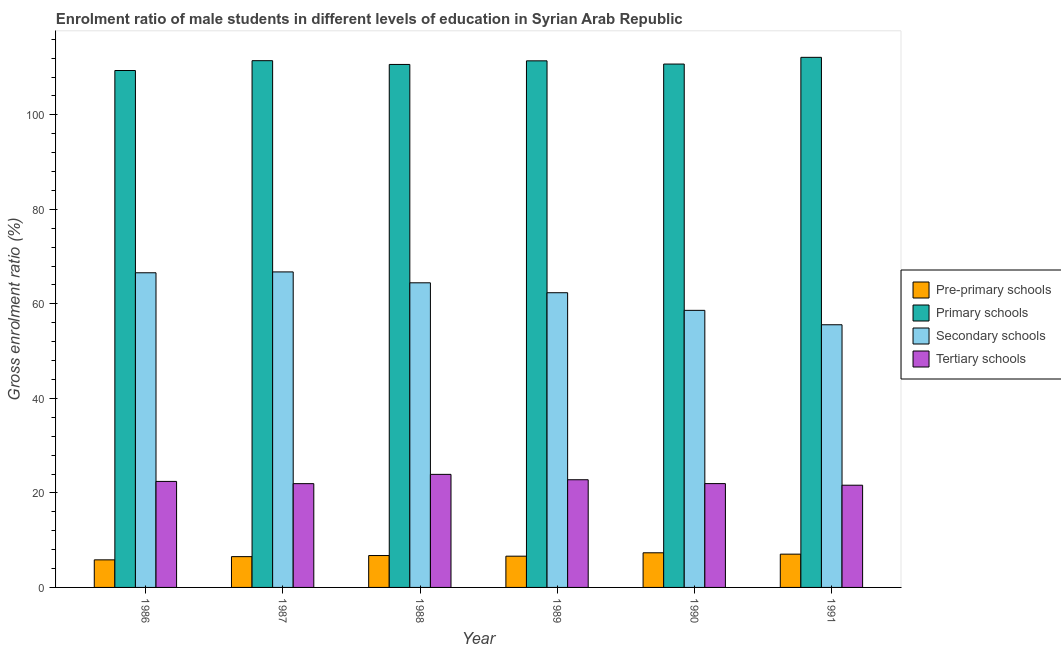How many groups of bars are there?
Keep it short and to the point. 6. How many bars are there on the 6th tick from the left?
Provide a succinct answer. 4. In how many cases, is the number of bars for a given year not equal to the number of legend labels?
Keep it short and to the point. 0. What is the gross enrolment ratio(female) in primary schools in 1990?
Ensure brevity in your answer.  110.74. Across all years, what is the maximum gross enrolment ratio(female) in pre-primary schools?
Your response must be concise. 7.33. Across all years, what is the minimum gross enrolment ratio(female) in secondary schools?
Offer a terse response. 55.58. In which year was the gross enrolment ratio(female) in pre-primary schools maximum?
Your response must be concise. 1990. What is the total gross enrolment ratio(female) in pre-primary schools in the graph?
Keep it short and to the point. 40.08. What is the difference between the gross enrolment ratio(female) in secondary schools in 1987 and that in 1988?
Provide a succinct answer. 2.3. What is the difference between the gross enrolment ratio(female) in pre-primary schools in 1989 and the gross enrolment ratio(female) in tertiary schools in 1990?
Provide a short and direct response. -0.72. What is the average gross enrolment ratio(female) in primary schools per year?
Provide a succinct answer. 110.97. What is the ratio of the gross enrolment ratio(female) in tertiary schools in 1990 to that in 1991?
Your response must be concise. 1.02. Is the gross enrolment ratio(female) in tertiary schools in 1987 less than that in 1990?
Offer a terse response. Yes. What is the difference between the highest and the second highest gross enrolment ratio(female) in pre-primary schools?
Provide a short and direct response. 0.29. What is the difference between the highest and the lowest gross enrolment ratio(female) in pre-primary schools?
Your answer should be very brief. 1.49. Is the sum of the gross enrolment ratio(female) in tertiary schools in 1987 and 1991 greater than the maximum gross enrolment ratio(female) in primary schools across all years?
Provide a succinct answer. Yes. What does the 3rd bar from the left in 1987 represents?
Your answer should be compact. Secondary schools. What does the 1st bar from the right in 1990 represents?
Offer a very short reply. Tertiary schools. Is it the case that in every year, the sum of the gross enrolment ratio(female) in pre-primary schools and gross enrolment ratio(female) in primary schools is greater than the gross enrolment ratio(female) in secondary schools?
Make the answer very short. Yes. How many bars are there?
Your answer should be compact. 24. How many years are there in the graph?
Your answer should be very brief. 6. Does the graph contain any zero values?
Give a very brief answer. No. Where does the legend appear in the graph?
Offer a terse response. Center right. How many legend labels are there?
Keep it short and to the point. 4. How are the legend labels stacked?
Keep it short and to the point. Vertical. What is the title of the graph?
Offer a very short reply. Enrolment ratio of male students in different levels of education in Syrian Arab Republic. Does "Quality of logistic services" appear as one of the legend labels in the graph?
Your answer should be compact. No. What is the label or title of the X-axis?
Your answer should be compact. Year. What is the label or title of the Y-axis?
Keep it short and to the point. Gross enrolment ratio (%). What is the Gross enrolment ratio (%) in Pre-primary schools in 1986?
Your response must be concise. 5.84. What is the Gross enrolment ratio (%) of Primary schools in 1986?
Ensure brevity in your answer.  109.38. What is the Gross enrolment ratio (%) of Secondary schools in 1986?
Offer a terse response. 66.58. What is the Gross enrolment ratio (%) of Tertiary schools in 1986?
Your answer should be very brief. 22.43. What is the Gross enrolment ratio (%) in Pre-primary schools in 1987?
Ensure brevity in your answer.  6.52. What is the Gross enrolment ratio (%) of Primary schools in 1987?
Offer a terse response. 111.46. What is the Gross enrolment ratio (%) of Secondary schools in 1987?
Make the answer very short. 66.76. What is the Gross enrolment ratio (%) of Tertiary schools in 1987?
Provide a succinct answer. 21.96. What is the Gross enrolment ratio (%) of Pre-primary schools in 1988?
Your answer should be compact. 6.75. What is the Gross enrolment ratio (%) in Primary schools in 1988?
Make the answer very short. 110.66. What is the Gross enrolment ratio (%) of Secondary schools in 1988?
Your response must be concise. 64.46. What is the Gross enrolment ratio (%) of Tertiary schools in 1988?
Provide a short and direct response. 23.92. What is the Gross enrolment ratio (%) of Pre-primary schools in 1989?
Keep it short and to the point. 6.61. What is the Gross enrolment ratio (%) of Primary schools in 1989?
Your response must be concise. 111.42. What is the Gross enrolment ratio (%) of Secondary schools in 1989?
Provide a short and direct response. 62.36. What is the Gross enrolment ratio (%) in Tertiary schools in 1989?
Your answer should be very brief. 22.78. What is the Gross enrolment ratio (%) of Pre-primary schools in 1990?
Provide a succinct answer. 7.33. What is the Gross enrolment ratio (%) in Primary schools in 1990?
Make the answer very short. 110.74. What is the Gross enrolment ratio (%) in Secondary schools in 1990?
Make the answer very short. 58.63. What is the Gross enrolment ratio (%) of Tertiary schools in 1990?
Provide a succinct answer. 21.97. What is the Gross enrolment ratio (%) of Pre-primary schools in 1991?
Provide a short and direct response. 7.04. What is the Gross enrolment ratio (%) in Primary schools in 1991?
Your answer should be compact. 112.17. What is the Gross enrolment ratio (%) in Secondary schools in 1991?
Provide a short and direct response. 55.58. What is the Gross enrolment ratio (%) of Tertiary schools in 1991?
Offer a very short reply. 21.63. Across all years, what is the maximum Gross enrolment ratio (%) of Pre-primary schools?
Your answer should be very brief. 7.33. Across all years, what is the maximum Gross enrolment ratio (%) in Primary schools?
Provide a succinct answer. 112.17. Across all years, what is the maximum Gross enrolment ratio (%) in Secondary schools?
Provide a short and direct response. 66.76. Across all years, what is the maximum Gross enrolment ratio (%) of Tertiary schools?
Keep it short and to the point. 23.92. Across all years, what is the minimum Gross enrolment ratio (%) in Pre-primary schools?
Ensure brevity in your answer.  5.84. Across all years, what is the minimum Gross enrolment ratio (%) in Primary schools?
Your answer should be compact. 109.38. Across all years, what is the minimum Gross enrolment ratio (%) of Secondary schools?
Provide a succinct answer. 55.58. Across all years, what is the minimum Gross enrolment ratio (%) in Tertiary schools?
Your answer should be compact. 21.63. What is the total Gross enrolment ratio (%) in Pre-primary schools in the graph?
Offer a very short reply. 40.08. What is the total Gross enrolment ratio (%) of Primary schools in the graph?
Offer a very short reply. 665.83. What is the total Gross enrolment ratio (%) of Secondary schools in the graph?
Ensure brevity in your answer.  374.36. What is the total Gross enrolment ratio (%) of Tertiary schools in the graph?
Provide a short and direct response. 134.69. What is the difference between the Gross enrolment ratio (%) in Pre-primary schools in 1986 and that in 1987?
Give a very brief answer. -0.68. What is the difference between the Gross enrolment ratio (%) of Primary schools in 1986 and that in 1987?
Keep it short and to the point. -2.08. What is the difference between the Gross enrolment ratio (%) in Secondary schools in 1986 and that in 1987?
Give a very brief answer. -0.18. What is the difference between the Gross enrolment ratio (%) of Tertiary schools in 1986 and that in 1987?
Offer a terse response. 0.47. What is the difference between the Gross enrolment ratio (%) of Pre-primary schools in 1986 and that in 1988?
Provide a short and direct response. -0.91. What is the difference between the Gross enrolment ratio (%) in Primary schools in 1986 and that in 1988?
Keep it short and to the point. -1.28. What is the difference between the Gross enrolment ratio (%) of Secondary schools in 1986 and that in 1988?
Provide a short and direct response. 2.12. What is the difference between the Gross enrolment ratio (%) in Tertiary schools in 1986 and that in 1988?
Offer a very short reply. -1.49. What is the difference between the Gross enrolment ratio (%) of Pre-primary schools in 1986 and that in 1989?
Provide a succinct answer. -0.78. What is the difference between the Gross enrolment ratio (%) in Primary schools in 1986 and that in 1989?
Offer a terse response. -2.05. What is the difference between the Gross enrolment ratio (%) of Secondary schools in 1986 and that in 1989?
Your response must be concise. 4.22. What is the difference between the Gross enrolment ratio (%) of Tertiary schools in 1986 and that in 1989?
Give a very brief answer. -0.35. What is the difference between the Gross enrolment ratio (%) of Pre-primary schools in 1986 and that in 1990?
Your answer should be very brief. -1.49. What is the difference between the Gross enrolment ratio (%) of Primary schools in 1986 and that in 1990?
Give a very brief answer. -1.37. What is the difference between the Gross enrolment ratio (%) in Secondary schools in 1986 and that in 1990?
Offer a terse response. 7.95. What is the difference between the Gross enrolment ratio (%) of Tertiary schools in 1986 and that in 1990?
Offer a very short reply. 0.47. What is the difference between the Gross enrolment ratio (%) in Pre-primary schools in 1986 and that in 1991?
Your answer should be compact. -1.21. What is the difference between the Gross enrolment ratio (%) of Primary schools in 1986 and that in 1991?
Provide a short and direct response. -2.79. What is the difference between the Gross enrolment ratio (%) of Secondary schools in 1986 and that in 1991?
Offer a very short reply. 11. What is the difference between the Gross enrolment ratio (%) in Tertiary schools in 1986 and that in 1991?
Make the answer very short. 0.8. What is the difference between the Gross enrolment ratio (%) in Pre-primary schools in 1987 and that in 1988?
Give a very brief answer. -0.23. What is the difference between the Gross enrolment ratio (%) of Primary schools in 1987 and that in 1988?
Your answer should be very brief. 0.8. What is the difference between the Gross enrolment ratio (%) of Secondary schools in 1987 and that in 1988?
Offer a very short reply. 2.3. What is the difference between the Gross enrolment ratio (%) of Tertiary schools in 1987 and that in 1988?
Keep it short and to the point. -1.96. What is the difference between the Gross enrolment ratio (%) in Pre-primary schools in 1987 and that in 1989?
Provide a short and direct response. -0.1. What is the difference between the Gross enrolment ratio (%) of Primary schools in 1987 and that in 1989?
Make the answer very short. 0.03. What is the difference between the Gross enrolment ratio (%) of Secondary schools in 1987 and that in 1989?
Ensure brevity in your answer.  4.4. What is the difference between the Gross enrolment ratio (%) of Tertiary schools in 1987 and that in 1989?
Give a very brief answer. -0.82. What is the difference between the Gross enrolment ratio (%) of Pre-primary schools in 1987 and that in 1990?
Your answer should be compact. -0.81. What is the difference between the Gross enrolment ratio (%) of Primary schools in 1987 and that in 1990?
Give a very brief answer. 0.71. What is the difference between the Gross enrolment ratio (%) in Secondary schools in 1987 and that in 1990?
Make the answer very short. 8.13. What is the difference between the Gross enrolment ratio (%) in Tertiary schools in 1987 and that in 1990?
Offer a terse response. -0.01. What is the difference between the Gross enrolment ratio (%) of Pre-primary schools in 1987 and that in 1991?
Offer a terse response. -0.53. What is the difference between the Gross enrolment ratio (%) in Primary schools in 1987 and that in 1991?
Make the answer very short. -0.71. What is the difference between the Gross enrolment ratio (%) in Secondary schools in 1987 and that in 1991?
Your answer should be very brief. 11.18. What is the difference between the Gross enrolment ratio (%) in Tertiary schools in 1987 and that in 1991?
Keep it short and to the point. 0.33. What is the difference between the Gross enrolment ratio (%) in Pre-primary schools in 1988 and that in 1989?
Give a very brief answer. 0.14. What is the difference between the Gross enrolment ratio (%) of Primary schools in 1988 and that in 1989?
Provide a short and direct response. -0.76. What is the difference between the Gross enrolment ratio (%) of Secondary schools in 1988 and that in 1989?
Your response must be concise. 2.1. What is the difference between the Gross enrolment ratio (%) of Tertiary schools in 1988 and that in 1989?
Offer a very short reply. 1.14. What is the difference between the Gross enrolment ratio (%) of Pre-primary schools in 1988 and that in 1990?
Provide a short and direct response. -0.58. What is the difference between the Gross enrolment ratio (%) in Primary schools in 1988 and that in 1990?
Your response must be concise. -0.08. What is the difference between the Gross enrolment ratio (%) of Secondary schools in 1988 and that in 1990?
Offer a terse response. 5.83. What is the difference between the Gross enrolment ratio (%) in Tertiary schools in 1988 and that in 1990?
Give a very brief answer. 1.95. What is the difference between the Gross enrolment ratio (%) in Pre-primary schools in 1988 and that in 1991?
Provide a succinct answer. -0.3. What is the difference between the Gross enrolment ratio (%) in Primary schools in 1988 and that in 1991?
Your response must be concise. -1.51. What is the difference between the Gross enrolment ratio (%) of Secondary schools in 1988 and that in 1991?
Provide a short and direct response. 8.88. What is the difference between the Gross enrolment ratio (%) of Tertiary schools in 1988 and that in 1991?
Give a very brief answer. 2.29. What is the difference between the Gross enrolment ratio (%) of Pre-primary schools in 1989 and that in 1990?
Ensure brevity in your answer.  -0.72. What is the difference between the Gross enrolment ratio (%) in Primary schools in 1989 and that in 1990?
Your answer should be very brief. 0.68. What is the difference between the Gross enrolment ratio (%) in Secondary schools in 1989 and that in 1990?
Make the answer very short. 3.73. What is the difference between the Gross enrolment ratio (%) of Tertiary schools in 1989 and that in 1990?
Make the answer very short. 0.82. What is the difference between the Gross enrolment ratio (%) in Pre-primary schools in 1989 and that in 1991?
Your answer should be compact. -0.43. What is the difference between the Gross enrolment ratio (%) of Primary schools in 1989 and that in 1991?
Provide a succinct answer. -0.74. What is the difference between the Gross enrolment ratio (%) in Secondary schools in 1989 and that in 1991?
Your answer should be compact. 6.78. What is the difference between the Gross enrolment ratio (%) of Tertiary schools in 1989 and that in 1991?
Keep it short and to the point. 1.15. What is the difference between the Gross enrolment ratio (%) in Pre-primary schools in 1990 and that in 1991?
Give a very brief answer. 0.29. What is the difference between the Gross enrolment ratio (%) in Primary schools in 1990 and that in 1991?
Ensure brevity in your answer.  -1.42. What is the difference between the Gross enrolment ratio (%) in Secondary schools in 1990 and that in 1991?
Give a very brief answer. 3.05. What is the difference between the Gross enrolment ratio (%) of Tertiary schools in 1990 and that in 1991?
Provide a short and direct response. 0.34. What is the difference between the Gross enrolment ratio (%) of Pre-primary schools in 1986 and the Gross enrolment ratio (%) of Primary schools in 1987?
Make the answer very short. -105.62. What is the difference between the Gross enrolment ratio (%) of Pre-primary schools in 1986 and the Gross enrolment ratio (%) of Secondary schools in 1987?
Offer a very short reply. -60.93. What is the difference between the Gross enrolment ratio (%) of Pre-primary schools in 1986 and the Gross enrolment ratio (%) of Tertiary schools in 1987?
Your answer should be very brief. -16.12. What is the difference between the Gross enrolment ratio (%) of Primary schools in 1986 and the Gross enrolment ratio (%) of Secondary schools in 1987?
Your answer should be compact. 42.62. What is the difference between the Gross enrolment ratio (%) in Primary schools in 1986 and the Gross enrolment ratio (%) in Tertiary schools in 1987?
Your answer should be compact. 87.42. What is the difference between the Gross enrolment ratio (%) of Secondary schools in 1986 and the Gross enrolment ratio (%) of Tertiary schools in 1987?
Keep it short and to the point. 44.62. What is the difference between the Gross enrolment ratio (%) in Pre-primary schools in 1986 and the Gross enrolment ratio (%) in Primary schools in 1988?
Offer a very short reply. -104.83. What is the difference between the Gross enrolment ratio (%) in Pre-primary schools in 1986 and the Gross enrolment ratio (%) in Secondary schools in 1988?
Keep it short and to the point. -58.62. What is the difference between the Gross enrolment ratio (%) in Pre-primary schools in 1986 and the Gross enrolment ratio (%) in Tertiary schools in 1988?
Ensure brevity in your answer.  -18.09. What is the difference between the Gross enrolment ratio (%) in Primary schools in 1986 and the Gross enrolment ratio (%) in Secondary schools in 1988?
Make the answer very short. 44.92. What is the difference between the Gross enrolment ratio (%) in Primary schools in 1986 and the Gross enrolment ratio (%) in Tertiary schools in 1988?
Your answer should be very brief. 85.46. What is the difference between the Gross enrolment ratio (%) of Secondary schools in 1986 and the Gross enrolment ratio (%) of Tertiary schools in 1988?
Provide a succinct answer. 42.66. What is the difference between the Gross enrolment ratio (%) in Pre-primary schools in 1986 and the Gross enrolment ratio (%) in Primary schools in 1989?
Ensure brevity in your answer.  -105.59. What is the difference between the Gross enrolment ratio (%) in Pre-primary schools in 1986 and the Gross enrolment ratio (%) in Secondary schools in 1989?
Offer a very short reply. -56.52. What is the difference between the Gross enrolment ratio (%) in Pre-primary schools in 1986 and the Gross enrolment ratio (%) in Tertiary schools in 1989?
Ensure brevity in your answer.  -16.95. What is the difference between the Gross enrolment ratio (%) of Primary schools in 1986 and the Gross enrolment ratio (%) of Secondary schools in 1989?
Make the answer very short. 47.02. What is the difference between the Gross enrolment ratio (%) of Primary schools in 1986 and the Gross enrolment ratio (%) of Tertiary schools in 1989?
Provide a short and direct response. 86.59. What is the difference between the Gross enrolment ratio (%) of Secondary schools in 1986 and the Gross enrolment ratio (%) of Tertiary schools in 1989?
Offer a terse response. 43.8. What is the difference between the Gross enrolment ratio (%) of Pre-primary schools in 1986 and the Gross enrolment ratio (%) of Primary schools in 1990?
Give a very brief answer. -104.91. What is the difference between the Gross enrolment ratio (%) of Pre-primary schools in 1986 and the Gross enrolment ratio (%) of Secondary schools in 1990?
Give a very brief answer. -52.79. What is the difference between the Gross enrolment ratio (%) of Pre-primary schools in 1986 and the Gross enrolment ratio (%) of Tertiary schools in 1990?
Provide a short and direct response. -16.13. What is the difference between the Gross enrolment ratio (%) of Primary schools in 1986 and the Gross enrolment ratio (%) of Secondary schools in 1990?
Offer a very short reply. 50.75. What is the difference between the Gross enrolment ratio (%) of Primary schools in 1986 and the Gross enrolment ratio (%) of Tertiary schools in 1990?
Your answer should be compact. 87.41. What is the difference between the Gross enrolment ratio (%) in Secondary schools in 1986 and the Gross enrolment ratio (%) in Tertiary schools in 1990?
Your answer should be very brief. 44.61. What is the difference between the Gross enrolment ratio (%) of Pre-primary schools in 1986 and the Gross enrolment ratio (%) of Primary schools in 1991?
Offer a terse response. -106.33. What is the difference between the Gross enrolment ratio (%) in Pre-primary schools in 1986 and the Gross enrolment ratio (%) in Secondary schools in 1991?
Ensure brevity in your answer.  -49.74. What is the difference between the Gross enrolment ratio (%) in Pre-primary schools in 1986 and the Gross enrolment ratio (%) in Tertiary schools in 1991?
Keep it short and to the point. -15.79. What is the difference between the Gross enrolment ratio (%) in Primary schools in 1986 and the Gross enrolment ratio (%) in Secondary schools in 1991?
Provide a short and direct response. 53.8. What is the difference between the Gross enrolment ratio (%) of Primary schools in 1986 and the Gross enrolment ratio (%) of Tertiary schools in 1991?
Keep it short and to the point. 87.75. What is the difference between the Gross enrolment ratio (%) of Secondary schools in 1986 and the Gross enrolment ratio (%) of Tertiary schools in 1991?
Give a very brief answer. 44.95. What is the difference between the Gross enrolment ratio (%) of Pre-primary schools in 1987 and the Gross enrolment ratio (%) of Primary schools in 1988?
Your answer should be compact. -104.15. What is the difference between the Gross enrolment ratio (%) of Pre-primary schools in 1987 and the Gross enrolment ratio (%) of Secondary schools in 1988?
Your response must be concise. -57.94. What is the difference between the Gross enrolment ratio (%) of Pre-primary schools in 1987 and the Gross enrolment ratio (%) of Tertiary schools in 1988?
Provide a short and direct response. -17.41. What is the difference between the Gross enrolment ratio (%) in Primary schools in 1987 and the Gross enrolment ratio (%) in Secondary schools in 1988?
Offer a very short reply. 47. What is the difference between the Gross enrolment ratio (%) in Primary schools in 1987 and the Gross enrolment ratio (%) in Tertiary schools in 1988?
Your response must be concise. 87.53. What is the difference between the Gross enrolment ratio (%) in Secondary schools in 1987 and the Gross enrolment ratio (%) in Tertiary schools in 1988?
Provide a short and direct response. 42.84. What is the difference between the Gross enrolment ratio (%) of Pre-primary schools in 1987 and the Gross enrolment ratio (%) of Primary schools in 1989?
Provide a short and direct response. -104.91. What is the difference between the Gross enrolment ratio (%) in Pre-primary schools in 1987 and the Gross enrolment ratio (%) in Secondary schools in 1989?
Give a very brief answer. -55.84. What is the difference between the Gross enrolment ratio (%) in Pre-primary schools in 1987 and the Gross enrolment ratio (%) in Tertiary schools in 1989?
Offer a terse response. -16.27. What is the difference between the Gross enrolment ratio (%) in Primary schools in 1987 and the Gross enrolment ratio (%) in Secondary schools in 1989?
Provide a succinct answer. 49.1. What is the difference between the Gross enrolment ratio (%) in Primary schools in 1987 and the Gross enrolment ratio (%) in Tertiary schools in 1989?
Your answer should be very brief. 88.67. What is the difference between the Gross enrolment ratio (%) in Secondary schools in 1987 and the Gross enrolment ratio (%) in Tertiary schools in 1989?
Give a very brief answer. 43.98. What is the difference between the Gross enrolment ratio (%) of Pre-primary schools in 1987 and the Gross enrolment ratio (%) of Primary schools in 1990?
Keep it short and to the point. -104.23. What is the difference between the Gross enrolment ratio (%) of Pre-primary schools in 1987 and the Gross enrolment ratio (%) of Secondary schools in 1990?
Your answer should be compact. -52.11. What is the difference between the Gross enrolment ratio (%) of Pre-primary schools in 1987 and the Gross enrolment ratio (%) of Tertiary schools in 1990?
Your response must be concise. -15.45. What is the difference between the Gross enrolment ratio (%) of Primary schools in 1987 and the Gross enrolment ratio (%) of Secondary schools in 1990?
Provide a succinct answer. 52.83. What is the difference between the Gross enrolment ratio (%) in Primary schools in 1987 and the Gross enrolment ratio (%) in Tertiary schools in 1990?
Your answer should be very brief. 89.49. What is the difference between the Gross enrolment ratio (%) in Secondary schools in 1987 and the Gross enrolment ratio (%) in Tertiary schools in 1990?
Your answer should be compact. 44.79. What is the difference between the Gross enrolment ratio (%) of Pre-primary schools in 1987 and the Gross enrolment ratio (%) of Primary schools in 1991?
Ensure brevity in your answer.  -105.65. What is the difference between the Gross enrolment ratio (%) of Pre-primary schools in 1987 and the Gross enrolment ratio (%) of Secondary schools in 1991?
Offer a terse response. -49.06. What is the difference between the Gross enrolment ratio (%) of Pre-primary schools in 1987 and the Gross enrolment ratio (%) of Tertiary schools in 1991?
Provide a succinct answer. -15.11. What is the difference between the Gross enrolment ratio (%) of Primary schools in 1987 and the Gross enrolment ratio (%) of Secondary schools in 1991?
Give a very brief answer. 55.88. What is the difference between the Gross enrolment ratio (%) in Primary schools in 1987 and the Gross enrolment ratio (%) in Tertiary schools in 1991?
Provide a short and direct response. 89.83. What is the difference between the Gross enrolment ratio (%) in Secondary schools in 1987 and the Gross enrolment ratio (%) in Tertiary schools in 1991?
Provide a short and direct response. 45.13. What is the difference between the Gross enrolment ratio (%) of Pre-primary schools in 1988 and the Gross enrolment ratio (%) of Primary schools in 1989?
Give a very brief answer. -104.68. What is the difference between the Gross enrolment ratio (%) in Pre-primary schools in 1988 and the Gross enrolment ratio (%) in Secondary schools in 1989?
Ensure brevity in your answer.  -55.61. What is the difference between the Gross enrolment ratio (%) in Pre-primary schools in 1988 and the Gross enrolment ratio (%) in Tertiary schools in 1989?
Provide a short and direct response. -16.04. What is the difference between the Gross enrolment ratio (%) in Primary schools in 1988 and the Gross enrolment ratio (%) in Secondary schools in 1989?
Make the answer very short. 48.3. What is the difference between the Gross enrolment ratio (%) in Primary schools in 1988 and the Gross enrolment ratio (%) in Tertiary schools in 1989?
Provide a succinct answer. 87.88. What is the difference between the Gross enrolment ratio (%) of Secondary schools in 1988 and the Gross enrolment ratio (%) of Tertiary schools in 1989?
Provide a succinct answer. 41.67. What is the difference between the Gross enrolment ratio (%) in Pre-primary schools in 1988 and the Gross enrolment ratio (%) in Primary schools in 1990?
Ensure brevity in your answer.  -104. What is the difference between the Gross enrolment ratio (%) in Pre-primary schools in 1988 and the Gross enrolment ratio (%) in Secondary schools in 1990?
Ensure brevity in your answer.  -51.88. What is the difference between the Gross enrolment ratio (%) of Pre-primary schools in 1988 and the Gross enrolment ratio (%) of Tertiary schools in 1990?
Provide a succinct answer. -15.22. What is the difference between the Gross enrolment ratio (%) of Primary schools in 1988 and the Gross enrolment ratio (%) of Secondary schools in 1990?
Provide a succinct answer. 52.03. What is the difference between the Gross enrolment ratio (%) in Primary schools in 1988 and the Gross enrolment ratio (%) in Tertiary schools in 1990?
Make the answer very short. 88.69. What is the difference between the Gross enrolment ratio (%) of Secondary schools in 1988 and the Gross enrolment ratio (%) of Tertiary schools in 1990?
Offer a very short reply. 42.49. What is the difference between the Gross enrolment ratio (%) in Pre-primary schools in 1988 and the Gross enrolment ratio (%) in Primary schools in 1991?
Give a very brief answer. -105.42. What is the difference between the Gross enrolment ratio (%) in Pre-primary schools in 1988 and the Gross enrolment ratio (%) in Secondary schools in 1991?
Offer a terse response. -48.83. What is the difference between the Gross enrolment ratio (%) of Pre-primary schools in 1988 and the Gross enrolment ratio (%) of Tertiary schools in 1991?
Ensure brevity in your answer.  -14.88. What is the difference between the Gross enrolment ratio (%) of Primary schools in 1988 and the Gross enrolment ratio (%) of Secondary schools in 1991?
Provide a succinct answer. 55.08. What is the difference between the Gross enrolment ratio (%) in Primary schools in 1988 and the Gross enrolment ratio (%) in Tertiary schools in 1991?
Your answer should be compact. 89.03. What is the difference between the Gross enrolment ratio (%) in Secondary schools in 1988 and the Gross enrolment ratio (%) in Tertiary schools in 1991?
Give a very brief answer. 42.83. What is the difference between the Gross enrolment ratio (%) of Pre-primary schools in 1989 and the Gross enrolment ratio (%) of Primary schools in 1990?
Make the answer very short. -104.13. What is the difference between the Gross enrolment ratio (%) of Pre-primary schools in 1989 and the Gross enrolment ratio (%) of Secondary schools in 1990?
Ensure brevity in your answer.  -52.02. What is the difference between the Gross enrolment ratio (%) in Pre-primary schools in 1989 and the Gross enrolment ratio (%) in Tertiary schools in 1990?
Give a very brief answer. -15.36. What is the difference between the Gross enrolment ratio (%) of Primary schools in 1989 and the Gross enrolment ratio (%) of Secondary schools in 1990?
Your answer should be very brief. 52.8. What is the difference between the Gross enrolment ratio (%) of Primary schools in 1989 and the Gross enrolment ratio (%) of Tertiary schools in 1990?
Ensure brevity in your answer.  89.46. What is the difference between the Gross enrolment ratio (%) of Secondary schools in 1989 and the Gross enrolment ratio (%) of Tertiary schools in 1990?
Your answer should be compact. 40.39. What is the difference between the Gross enrolment ratio (%) in Pre-primary schools in 1989 and the Gross enrolment ratio (%) in Primary schools in 1991?
Your response must be concise. -105.56. What is the difference between the Gross enrolment ratio (%) in Pre-primary schools in 1989 and the Gross enrolment ratio (%) in Secondary schools in 1991?
Offer a terse response. -48.97. What is the difference between the Gross enrolment ratio (%) of Pre-primary schools in 1989 and the Gross enrolment ratio (%) of Tertiary schools in 1991?
Keep it short and to the point. -15.02. What is the difference between the Gross enrolment ratio (%) of Primary schools in 1989 and the Gross enrolment ratio (%) of Secondary schools in 1991?
Provide a short and direct response. 55.84. What is the difference between the Gross enrolment ratio (%) in Primary schools in 1989 and the Gross enrolment ratio (%) in Tertiary schools in 1991?
Keep it short and to the point. 89.79. What is the difference between the Gross enrolment ratio (%) in Secondary schools in 1989 and the Gross enrolment ratio (%) in Tertiary schools in 1991?
Your response must be concise. 40.73. What is the difference between the Gross enrolment ratio (%) of Pre-primary schools in 1990 and the Gross enrolment ratio (%) of Primary schools in 1991?
Your answer should be compact. -104.84. What is the difference between the Gross enrolment ratio (%) of Pre-primary schools in 1990 and the Gross enrolment ratio (%) of Secondary schools in 1991?
Offer a terse response. -48.25. What is the difference between the Gross enrolment ratio (%) in Pre-primary schools in 1990 and the Gross enrolment ratio (%) in Tertiary schools in 1991?
Provide a short and direct response. -14.3. What is the difference between the Gross enrolment ratio (%) in Primary schools in 1990 and the Gross enrolment ratio (%) in Secondary schools in 1991?
Provide a short and direct response. 55.16. What is the difference between the Gross enrolment ratio (%) of Primary schools in 1990 and the Gross enrolment ratio (%) of Tertiary schools in 1991?
Give a very brief answer. 89.11. What is the difference between the Gross enrolment ratio (%) of Secondary schools in 1990 and the Gross enrolment ratio (%) of Tertiary schools in 1991?
Keep it short and to the point. 37. What is the average Gross enrolment ratio (%) in Pre-primary schools per year?
Ensure brevity in your answer.  6.68. What is the average Gross enrolment ratio (%) of Primary schools per year?
Make the answer very short. 110.97. What is the average Gross enrolment ratio (%) in Secondary schools per year?
Your response must be concise. 62.39. What is the average Gross enrolment ratio (%) of Tertiary schools per year?
Ensure brevity in your answer.  22.45. In the year 1986, what is the difference between the Gross enrolment ratio (%) in Pre-primary schools and Gross enrolment ratio (%) in Primary schools?
Provide a short and direct response. -103.54. In the year 1986, what is the difference between the Gross enrolment ratio (%) in Pre-primary schools and Gross enrolment ratio (%) in Secondary schools?
Keep it short and to the point. -60.75. In the year 1986, what is the difference between the Gross enrolment ratio (%) in Pre-primary schools and Gross enrolment ratio (%) in Tertiary schools?
Provide a short and direct response. -16.6. In the year 1986, what is the difference between the Gross enrolment ratio (%) in Primary schools and Gross enrolment ratio (%) in Secondary schools?
Offer a terse response. 42.8. In the year 1986, what is the difference between the Gross enrolment ratio (%) of Primary schools and Gross enrolment ratio (%) of Tertiary schools?
Provide a short and direct response. 86.95. In the year 1986, what is the difference between the Gross enrolment ratio (%) in Secondary schools and Gross enrolment ratio (%) in Tertiary schools?
Provide a succinct answer. 44.15. In the year 1987, what is the difference between the Gross enrolment ratio (%) in Pre-primary schools and Gross enrolment ratio (%) in Primary schools?
Your answer should be compact. -104.94. In the year 1987, what is the difference between the Gross enrolment ratio (%) in Pre-primary schools and Gross enrolment ratio (%) in Secondary schools?
Provide a short and direct response. -60.25. In the year 1987, what is the difference between the Gross enrolment ratio (%) of Pre-primary schools and Gross enrolment ratio (%) of Tertiary schools?
Offer a very short reply. -15.44. In the year 1987, what is the difference between the Gross enrolment ratio (%) in Primary schools and Gross enrolment ratio (%) in Secondary schools?
Ensure brevity in your answer.  44.7. In the year 1987, what is the difference between the Gross enrolment ratio (%) in Primary schools and Gross enrolment ratio (%) in Tertiary schools?
Your answer should be very brief. 89.5. In the year 1987, what is the difference between the Gross enrolment ratio (%) in Secondary schools and Gross enrolment ratio (%) in Tertiary schools?
Offer a terse response. 44.8. In the year 1988, what is the difference between the Gross enrolment ratio (%) of Pre-primary schools and Gross enrolment ratio (%) of Primary schools?
Offer a terse response. -103.91. In the year 1988, what is the difference between the Gross enrolment ratio (%) of Pre-primary schools and Gross enrolment ratio (%) of Secondary schools?
Make the answer very short. -57.71. In the year 1988, what is the difference between the Gross enrolment ratio (%) of Pre-primary schools and Gross enrolment ratio (%) of Tertiary schools?
Ensure brevity in your answer.  -17.18. In the year 1988, what is the difference between the Gross enrolment ratio (%) of Primary schools and Gross enrolment ratio (%) of Secondary schools?
Make the answer very short. 46.2. In the year 1988, what is the difference between the Gross enrolment ratio (%) of Primary schools and Gross enrolment ratio (%) of Tertiary schools?
Provide a succinct answer. 86.74. In the year 1988, what is the difference between the Gross enrolment ratio (%) of Secondary schools and Gross enrolment ratio (%) of Tertiary schools?
Your answer should be compact. 40.54. In the year 1989, what is the difference between the Gross enrolment ratio (%) of Pre-primary schools and Gross enrolment ratio (%) of Primary schools?
Your answer should be very brief. -104.81. In the year 1989, what is the difference between the Gross enrolment ratio (%) of Pre-primary schools and Gross enrolment ratio (%) of Secondary schools?
Your answer should be very brief. -55.75. In the year 1989, what is the difference between the Gross enrolment ratio (%) of Pre-primary schools and Gross enrolment ratio (%) of Tertiary schools?
Ensure brevity in your answer.  -16.17. In the year 1989, what is the difference between the Gross enrolment ratio (%) of Primary schools and Gross enrolment ratio (%) of Secondary schools?
Make the answer very short. 49.07. In the year 1989, what is the difference between the Gross enrolment ratio (%) in Primary schools and Gross enrolment ratio (%) in Tertiary schools?
Offer a very short reply. 88.64. In the year 1989, what is the difference between the Gross enrolment ratio (%) of Secondary schools and Gross enrolment ratio (%) of Tertiary schools?
Your answer should be compact. 39.57. In the year 1990, what is the difference between the Gross enrolment ratio (%) in Pre-primary schools and Gross enrolment ratio (%) in Primary schools?
Ensure brevity in your answer.  -103.41. In the year 1990, what is the difference between the Gross enrolment ratio (%) in Pre-primary schools and Gross enrolment ratio (%) in Secondary schools?
Offer a very short reply. -51.3. In the year 1990, what is the difference between the Gross enrolment ratio (%) in Pre-primary schools and Gross enrolment ratio (%) in Tertiary schools?
Your answer should be compact. -14.64. In the year 1990, what is the difference between the Gross enrolment ratio (%) of Primary schools and Gross enrolment ratio (%) of Secondary schools?
Keep it short and to the point. 52.12. In the year 1990, what is the difference between the Gross enrolment ratio (%) of Primary schools and Gross enrolment ratio (%) of Tertiary schools?
Offer a very short reply. 88.78. In the year 1990, what is the difference between the Gross enrolment ratio (%) in Secondary schools and Gross enrolment ratio (%) in Tertiary schools?
Your answer should be very brief. 36.66. In the year 1991, what is the difference between the Gross enrolment ratio (%) in Pre-primary schools and Gross enrolment ratio (%) in Primary schools?
Your response must be concise. -105.12. In the year 1991, what is the difference between the Gross enrolment ratio (%) in Pre-primary schools and Gross enrolment ratio (%) in Secondary schools?
Your response must be concise. -48.54. In the year 1991, what is the difference between the Gross enrolment ratio (%) of Pre-primary schools and Gross enrolment ratio (%) of Tertiary schools?
Offer a terse response. -14.59. In the year 1991, what is the difference between the Gross enrolment ratio (%) of Primary schools and Gross enrolment ratio (%) of Secondary schools?
Your answer should be very brief. 56.59. In the year 1991, what is the difference between the Gross enrolment ratio (%) of Primary schools and Gross enrolment ratio (%) of Tertiary schools?
Give a very brief answer. 90.54. In the year 1991, what is the difference between the Gross enrolment ratio (%) in Secondary schools and Gross enrolment ratio (%) in Tertiary schools?
Your response must be concise. 33.95. What is the ratio of the Gross enrolment ratio (%) in Pre-primary schools in 1986 to that in 1987?
Your answer should be very brief. 0.9. What is the ratio of the Gross enrolment ratio (%) in Primary schools in 1986 to that in 1987?
Your response must be concise. 0.98. What is the ratio of the Gross enrolment ratio (%) in Tertiary schools in 1986 to that in 1987?
Make the answer very short. 1.02. What is the ratio of the Gross enrolment ratio (%) in Pre-primary schools in 1986 to that in 1988?
Ensure brevity in your answer.  0.86. What is the ratio of the Gross enrolment ratio (%) of Primary schools in 1986 to that in 1988?
Provide a short and direct response. 0.99. What is the ratio of the Gross enrolment ratio (%) in Secondary schools in 1986 to that in 1988?
Provide a succinct answer. 1.03. What is the ratio of the Gross enrolment ratio (%) in Tertiary schools in 1986 to that in 1988?
Ensure brevity in your answer.  0.94. What is the ratio of the Gross enrolment ratio (%) of Pre-primary schools in 1986 to that in 1989?
Your answer should be compact. 0.88. What is the ratio of the Gross enrolment ratio (%) in Primary schools in 1986 to that in 1989?
Offer a terse response. 0.98. What is the ratio of the Gross enrolment ratio (%) in Secondary schools in 1986 to that in 1989?
Provide a short and direct response. 1.07. What is the ratio of the Gross enrolment ratio (%) in Tertiary schools in 1986 to that in 1989?
Provide a short and direct response. 0.98. What is the ratio of the Gross enrolment ratio (%) in Pre-primary schools in 1986 to that in 1990?
Keep it short and to the point. 0.8. What is the ratio of the Gross enrolment ratio (%) of Secondary schools in 1986 to that in 1990?
Make the answer very short. 1.14. What is the ratio of the Gross enrolment ratio (%) of Tertiary schools in 1986 to that in 1990?
Make the answer very short. 1.02. What is the ratio of the Gross enrolment ratio (%) of Pre-primary schools in 1986 to that in 1991?
Offer a terse response. 0.83. What is the ratio of the Gross enrolment ratio (%) of Primary schools in 1986 to that in 1991?
Your response must be concise. 0.98. What is the ratio of the Gross enrolment ratio (%) in Secondary schools in 1986 to that in 1991?
Ensure brevity in your answer.  1.2. What is the ratio of the Gross enrolment ratio (%) in Tertiary schools in 1986 to that in 1991?
Your answer should be very brief. 1.04. What is the ratio of the Gross enrolment ratio (%) in Pre-primary schools in 1987 to that in 1988?
Your response must be concise. 0.97. What is the ratio of the Gross enrolment ratio (%) of Primary schools in 1987 to that in 1988?
Provide a short and direct response. 1.01. What is the ratio of the Gross enrolment ratio (%) in Secondary schools in 1987 to that in 1988?
Provide a short and direct response. 1.04. What is the ratio of the Gross enrolment ratio (%) in Tertiary schools in 1987 to that in 1988?
Keep it short and to the point. 0.92. What is the ratio of the Gross enrolment ratio (%) of Pre-primary schools in 1987 to that in 1989?
Offer a very short reply. 0.99. What is the ratio of the Gross enrolment ratio (%) in Primary schools in 1987 to that in 1989?
Give a very brief answer. 1. What is the ratio of the Gross enrolment ratio (%) in Secondary schools in 1987 to that in 1989?
Provide a short and direct response. 1.07. What is the ratio of the Gross enrolment ratio (%) in Tertiary schools in 1987 to that in 1989?
Provide a short and direct response. 0.96. What is the ratio of the Gross enrolment ratio (%) in Pre-primary schools in 1987 to that in 1990?
Your answer should be compact. 0.89. What is the ratio of the Gross enrolment ratio (%) of Primary schools in 1987 to that in 1990?
Your answer should be compact. 1.01. What is the ratio of the Gross enrolment ratio (%) of Secondary schools in 1987 to that in 1990?
Keep it short and to the point. 1.14. What is the ratio of the Gross enrolment ratio (%) of Tertiary schools in 1987 to that in 1990?
Ensure brevity in your answer.  1. What is the ratio of the Gross enrolment ratio (%) in Pre-primary schools in 1987 to that in 1991?
Your response must be concise. 0.93. What is the ratio of the Gross enrolment ratio (%) in Primary schools in 1987 to that in 1991?
Provide a short and direct response. 0.99. What is the ratio of the Gross enrolment ratio (%) in Secondary schools in 1987 to that in 1991?
Provide a short and direct response. 1.2. What is the ratio of the Gross enrolment ratio (%) in Tertiary schools in 1987 to that in 1991?
Give a very brief answer. 1.02. What is the ratio of the Gross enrolment ratio (%) in Pre-primary schools in 1988 to that in 1989?
Keep it short and to the point. 1.02. What is the ratio of the Gross enrolment ratio (%) of Secondary schools in 1988 to that in 1989?
Give a very brief answer. 1.03. What is the ratio of the Gross enrolment ratio (%) of Tertiary schools in 1988 to that in 1989?
Keep it short and to the point. 1.05. What is the ratio of the Gross enrolment ratio (%) in Pre-primary schools in 1988 to that in 1990?
Give a very brief answer. 0.92. What is the ratio of the Gross enrolment ratio (%) of Secondary schools in 1988 to that in 1990?
Keep it short and to the point. 1.1. What is the ratio of the Gross enrolment ratio (%) in Tertiary schools in 1988 to that in 1990?
Offer a terse response. 1.09. What is the ratio of the Gross enrolment ratio (%) in Pre-primary schools in 1988 to that in 1991?
Your answer should be very brief. 0.96. What is the ratio of the Gross enrolment ratio (%) in Primary schools in 1988 to that in 1991?
Your answer should be very brief. 0.99. What is the ratio of the Gross enrolment ratio (%) in Secondary schools in 1988 to that in 1991?
Your response must be concise. 1.16. What is the ratio of the Gross enrolment ratio (%) of Tertiary schools in 1988 to that in 1991?
Keep it short and to the point. 1.11. What is the ratio of the Gross enrolment ratio (%) in Pre-primary schools in 1989 to that in 1990?
Your response must be concise. 0.9. What is the ratio of the Gross enrolment ratio (%) of Primary schools in 1989 to that in 1990?
Keep it short and to the point. 1.01. What is the ratio of the Gross enrolment ratio (%) in Secondary schools in 1989 to that in 1990?
Offer a very short reply. 1.06. What is the ratio of the Gross enrolment ratio (%) in Tertiary schools in 1989 to that in 1990?
Your response must be concise. 1.04. What is the ratio of the Gross enrolment ratio (%) in Pre-primary schools in 1989 to that in 1991?
Provide a succinct answer. 0.94. What is the ratio of the Gross enrolment ratio (%) in Secondary schools in 1989 to that in 1991?
Your response must be concise. 1.12. What is the ratio of the Gross enrolment ratio (%) of Tertiary schools in 1989 to that in 1991?
Provide a succinct answer. 1.05. What is the ratio of the Gross enrolment ratio (%) of Pre-primary schools in 1990 to that in 1991?
Your response must be concise. 1.04. What is the ratio of the Gross enrolment ratio (%) of Primary schools in 1990 to that in 1991?
Make the answer very short. 0.99. What is the ratio of the Gross enrolment ratio (%) in Secondary schools in 1990 to that in 1991?
Your response must be concise. 1.05. What is the ratio of the Gross enrolment ratio (%) in Tertiary schools in 1990 to that in 1991?
Make the answer very short. 1.02. What is the difference between the highest and the second highest Gross enrolment ratio (%) of Pre-primary schools?
Your answer should be very brief. 0.29. What is the difference between the highest and the second highest Gross enrolment ratio (%) of Primary schools?
Your answer should be very brief. 0.71. What is the difference between the highest and the second highest Gross enrolment ratio (%) of Secondary schools?
Keep it short and to the point. 0.18. What is the difference between the highest and the second highest Gross enrolment ratio (%) of Tertiary schools?
Make the answer very short. 1.14. What is the difference between the highest and the lowest Gross enrolment ratio (%) of Pre-primary schools?
Offer a terse response. 1.49. What is the difference between the highest and the lowest Gross enrolment ratio (%) in Primary schools?
Give a very brief answer. 2.79. What is the difference between the highest and the lowest Gross enrolment ratio (%) in Secondary schools?
Provide a succinct answer. 11.18. What is the difference between the highest and the lowest Gross enrolment ratio (%) in Tertiary schools?
Your answer should be very brief. 2.29. 